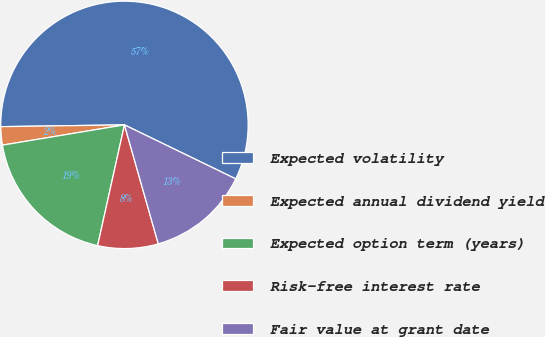Convert chart. <chart><loc_0><loc_0><loc_500><loc_500><pie_chart><fcel>Expected volatility<fcel>Expected annual dividend yield<fcel>Expected option term (years)<fcel>Risk-free interest rate<fcel>Fair value at grant date<nl><fcel>57.42%<fcel>2.39%<fcel>18.9%<fcel>7.89%<fcel>13.4%<nl></chart> 